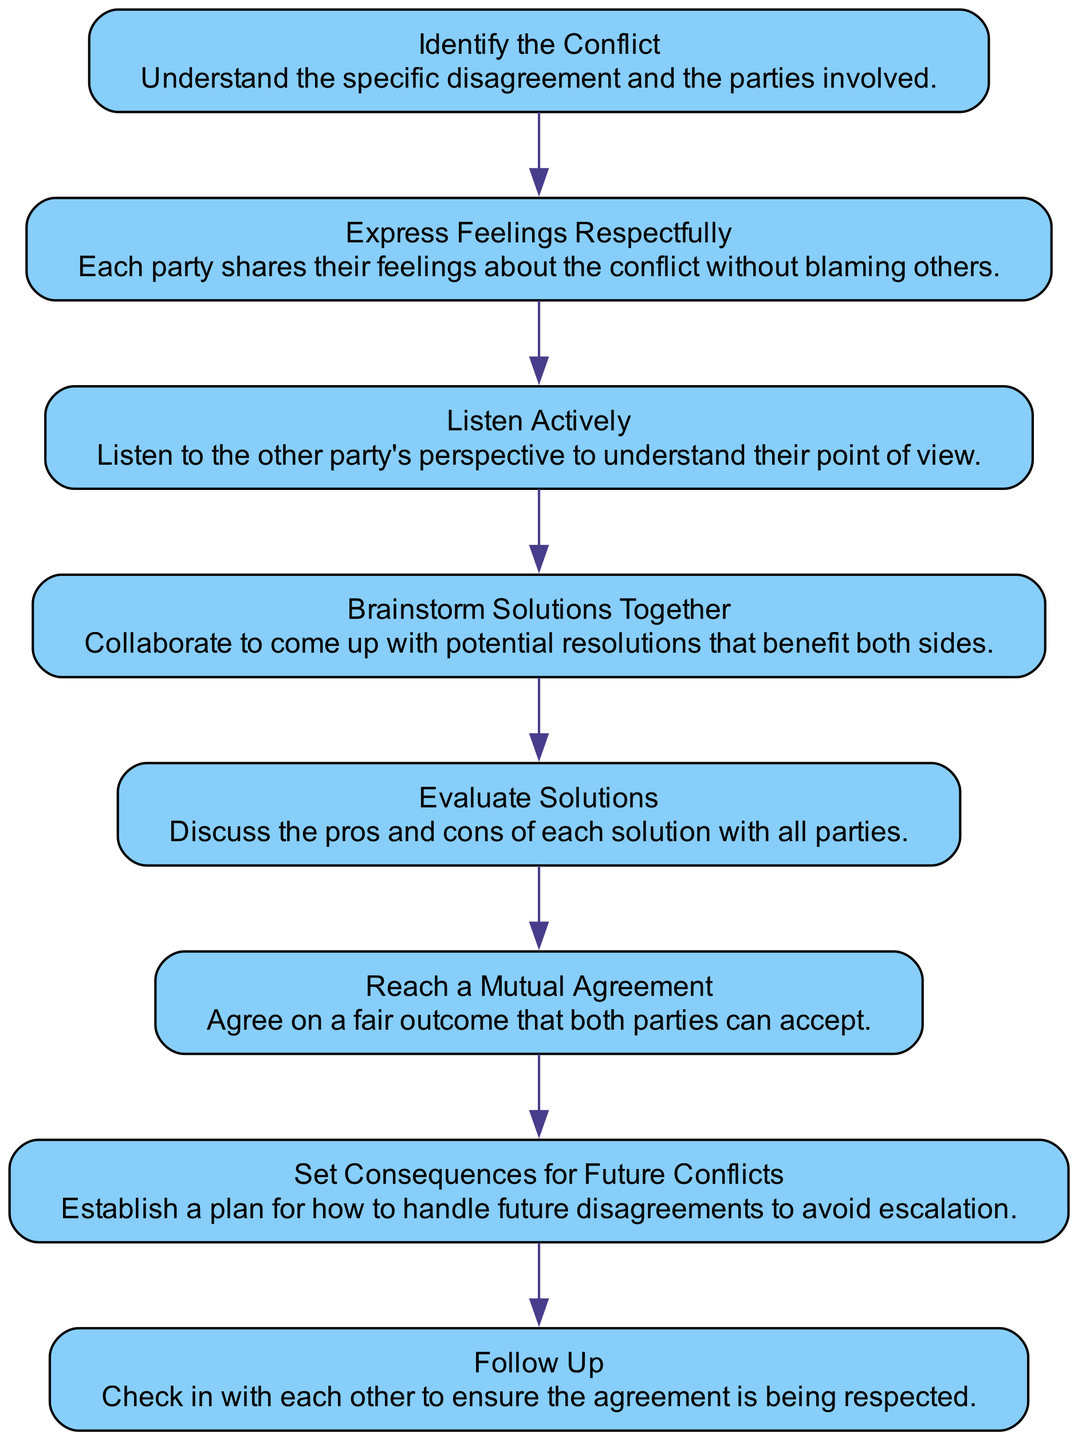What is the first step in the flow chart? The first step is "Identify the Conflict," which is the starting point of the process. It involves understanding the specific disagreement and the parties involved.
Answer: Identify the Conflict How many total nodes are in the diagram? There are eight nodes total in the diagram, as listed from "Identify the Conflict" to "Follow Up."
Answer: 8 What is the label of the last node in the flow chart? The last node is labeled "Follow Up," which indicates the final step of checking in to ensure the agreement is respected.
Answer: Follow Up What comes immediately after "Listen Actively"? After "Listen Actively," the next step is "Brainstorm Solutions Together," where the involved parties work collaboratively to find resolutions.
Answer: Brainstorm Solutions Together What action is taken after reaching a mutual agreement? After reaching a mutual agreement, the next action is to "Set Consequences for Future Conflicts," which establishes a plan for handling potential disagreements in the future.
Answer: Set Consequences for Future Conflicts Which node illustrates the need for active communication between parties? The node "Express Feelings Respectfully" emphasizes the importance of communication, where each party shares their feelings without placing blame.
Answer: Express Feelings Respectfully How do you move from "Evaluate Solutions" to the next step? You move from "Evaluate Solutions" to "Reach a Mutual Agreement," as evaluating the solutions helps the parties come to a consensus on the best option.
Answer: Reach a Mutual Agreement What is described in the "Brainstorm Solutions Together" node? This node describes the collaborative effort to generate potential resolutions that consider both parties' needs and concerns, fostering teamwork.
Answer: Collaborate to come up with potential resolutions What is the purpose of the "Follow Up" step? The purpose of the "Follow Up" step is to check in with each other to ensure that the agreement made is being respected and held by both parties.
Answer: Ensure the agreement is respected 